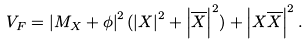<formula> <loc_0><loc_0><loc_500><loc_500>V _ { F } = \left | M _ { X } + \phi \right | ^ { 2 } ( \left | X \right | ^ { 2 } + \left | \overline { X } \right | ^ { 2 } ) + \left | X \overline { X } \right | ^ { 2 } .</formula> 